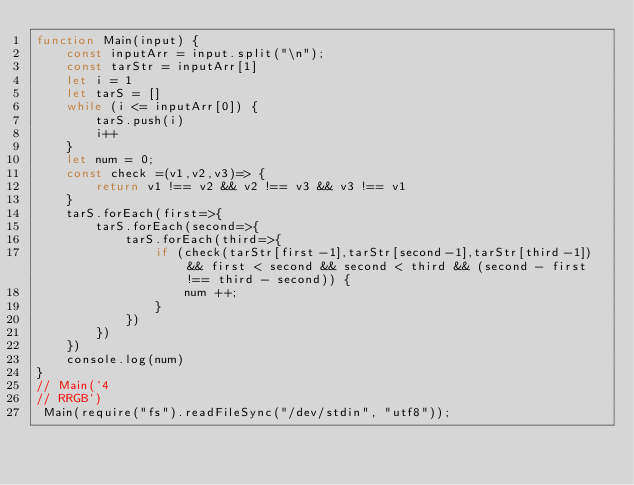Convert code to text. <code><loc_0><loc_0><loc_500><loc_500><_JavaScript_>function Main(input) {
    const inputArr = input.split("\n");
    const tarStr = inputArr[1]
    let i = 1
    let tarS = []
    while (i <= inputArr[0]) {
        tarS.push(i)
        i++
    }
    let num = 0;
    const check =(v1,v2,v3)=> {
        return v1 !== v2 && v2 !== v3 && v3 !== v1
    }
    tarS.forEach(first=>{
        tarS.forEach(second=>{
            tarS.forEach(third=>{
                if (check(tarStr[first-1],tarStr[second-1],tarStr[third-1]) && first < second && second < third && (second - first !== third - second)) {
                    num ++;
                }
            })
        })
    })
    console.log(num)
}
// Main(`4
// RRGB`)
 Main(require("fs").readFileSync("/dev/stdin", "utf8"));
</code> 